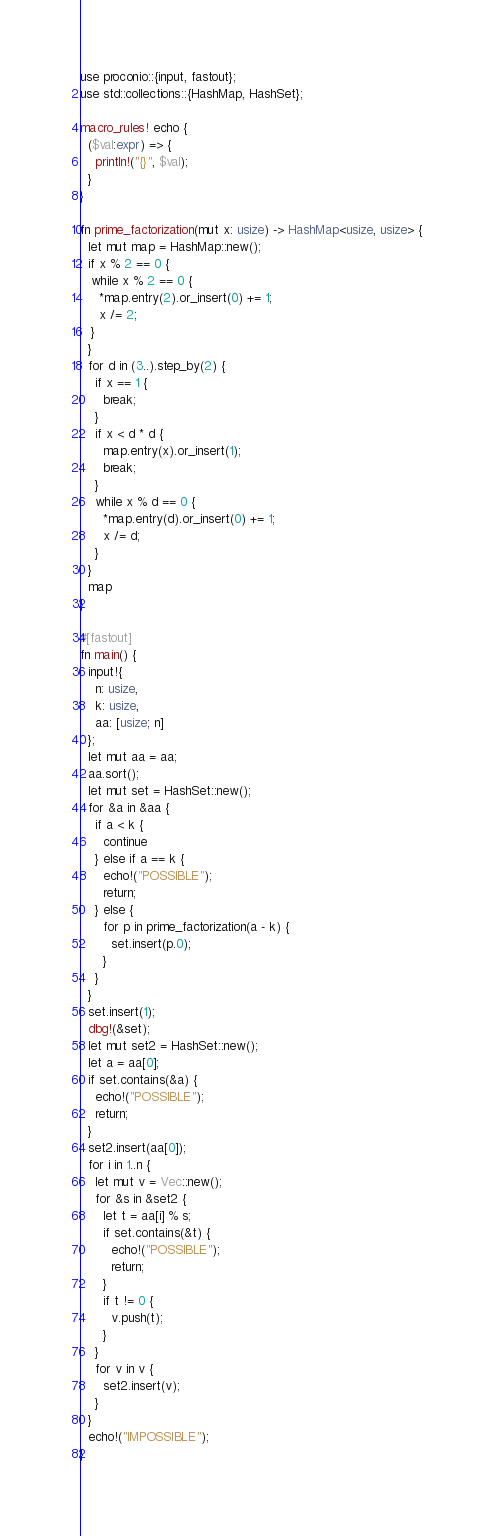<code> <loc_0><loc_0><loc_500><loc_500><_Rust_>use proconio::{input, fastout};
use std::collections::{HashMap, HashSet};

macro_rules! echo {
  ($val:expr) => {
    println!("{}", $val);
  }
}

fn prime_factorization(mut x: usize) -> HashMap<usize, usize> {
  let mut map = HashMap::new();
  if x % 2 == 0 {
   while x % 2 == 0 {
     *map.entry(2).or_insert(0) += 1; 
     x /= 2;
   }
  }
  for d in (3..).step_by(2) {
    if x == 1 {
      break;
    }
    if x < d * d {
      map.entry(x).or_insert(1);
      break;
    }
    while x % d == 0 {
      *map.entry(d).or_insert(0) += 1; 
      x /= d;
    }
  }
  map
}

#[fastout]
fn main() {
  input!{
    n: usize,
    k: usize,
    aa: [usize; n]
  };
  let mut aa = aa;
  aa.sort();
  let mut set = HashSet::new();
  for &a in &aa {
    if a < k {
      continue
    } else if a == k {
      echo!("POSSIBLE");
      return;
    } else {
      for p in prime_factorization(a - k) {
        set.insert(p.0);
      }
    }
  }
  set.insert(1);
  dbg!(&set);
  let mut set2 = HashSet::new();
  let a = aa[0];
  if set.contains(&a) {
    echo!("POSSIBLE");
    return;
  }
  set2.insert(aa[0]);
  for i in 1..n {
    let mut v = Vec::new();
    for &s in &set2 {
      let t = aa[i] % s;
      if set.contains(&t) {
        echo!("POSSIBLE");
        return;
      }
      if t != 0 {
        v.push(t);
      }
    }
    for v in v {
      set2.insert(v);
    }
  }
  echo!("IMPOSSIBLE");
}
</code> 